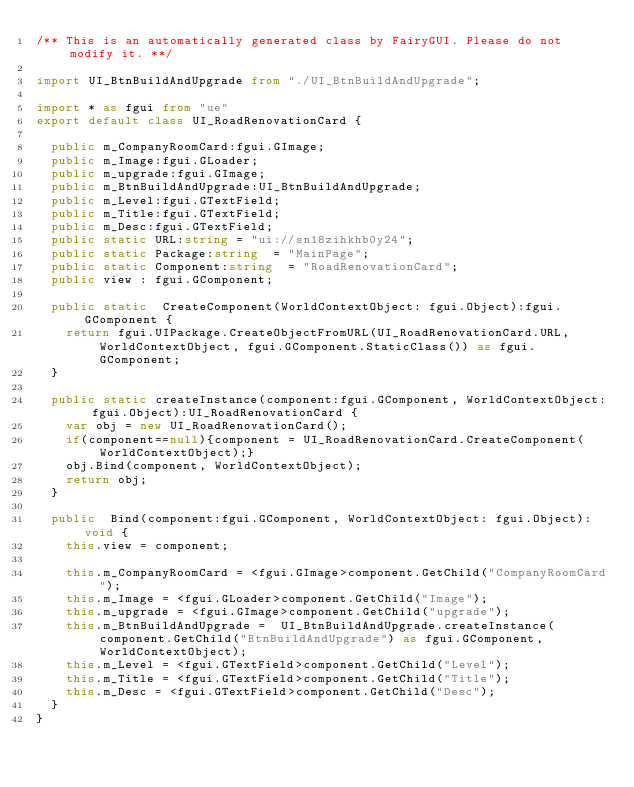Convert code to text. <code><loc_0><loc_0><loc_500><loc_500><_TypeScript_>/** This is an automatically generated class by FairyGUI. Please do not modify it. **/

import UI_BtnBuildAndUpgrade from "./UI_BtnBuildAndUpgrade";

import * as fgui from "ue"
export default class UI_RoadRenovationCard {

	public m_CompanyRoomCard:fgui.GImage;
	public m_Image:fgui.GLoader;
	public m_upgrade:fgui.GImage;
	public m_BtnBuildAndUpgrade:UI_BtnBuildAndUpgrade;
	public m_Level:fgui.GTextField;
	public m_Title:fgui.GTextField;
	public m_Desc:fgui.GTextField;
	public static URL:string = "ui://sn18zihkhb0y24";
	public static Package:string  = "MainPage";
	public static Component:string  = "RoadRenovationCard";
	public view : fgui.GComponent;

	public static  CreateComponent(WorldContextObject: fgui.Object):fgui.GComponent {
		return fgui.UIPackage.CreateObjectFromURL(UI_RoadRenovationCard.URL, WorldContextObject, fgui.GComponent.StaticClass()) as fgui.GComponent;
	}

	public static createInstance(component:fgui.GComponent, WorldContextObject: fgui.Object):UI_RoadRenovationCard {
		var obj = new UI_RoadRenovationCard();
		if(component==null){component = UI_RoadRenovationCard.CreateComponent(WorldContextObject);}
		obj.Bind(component, WorldContextObject);
		return obj;
	}

	public  Bind(component:fgui.GComponent, WorldContextObject: fgui.Object):void {
		this.view = component;

		this.m_CompanyRoomCard = <fgui.GImage>component.GetChild("CompanyRoomCard");
		this.m_Image = <fgui.GLoader>component.GetChild("Image");
		this.m_upgrade = <fgui.GImage>component.GetChild("upgrade");
		this.m_BtnBuildAndUpgrade =  UI_BtnBuildAndUpgrade.createInstance(component.GetChild("BtnBuildAndUpgrade") as fgui.GComponent, WorldContextObject);
		this.m_Level = <fgui.GTextField>component.GetChild("Level");
		this.m_Title = <fgui.GTextField>component.GetChild("Title");
		this.m_Desc = <fgui.GTextField>component.GetChild("Desc");
	}
}</code> 